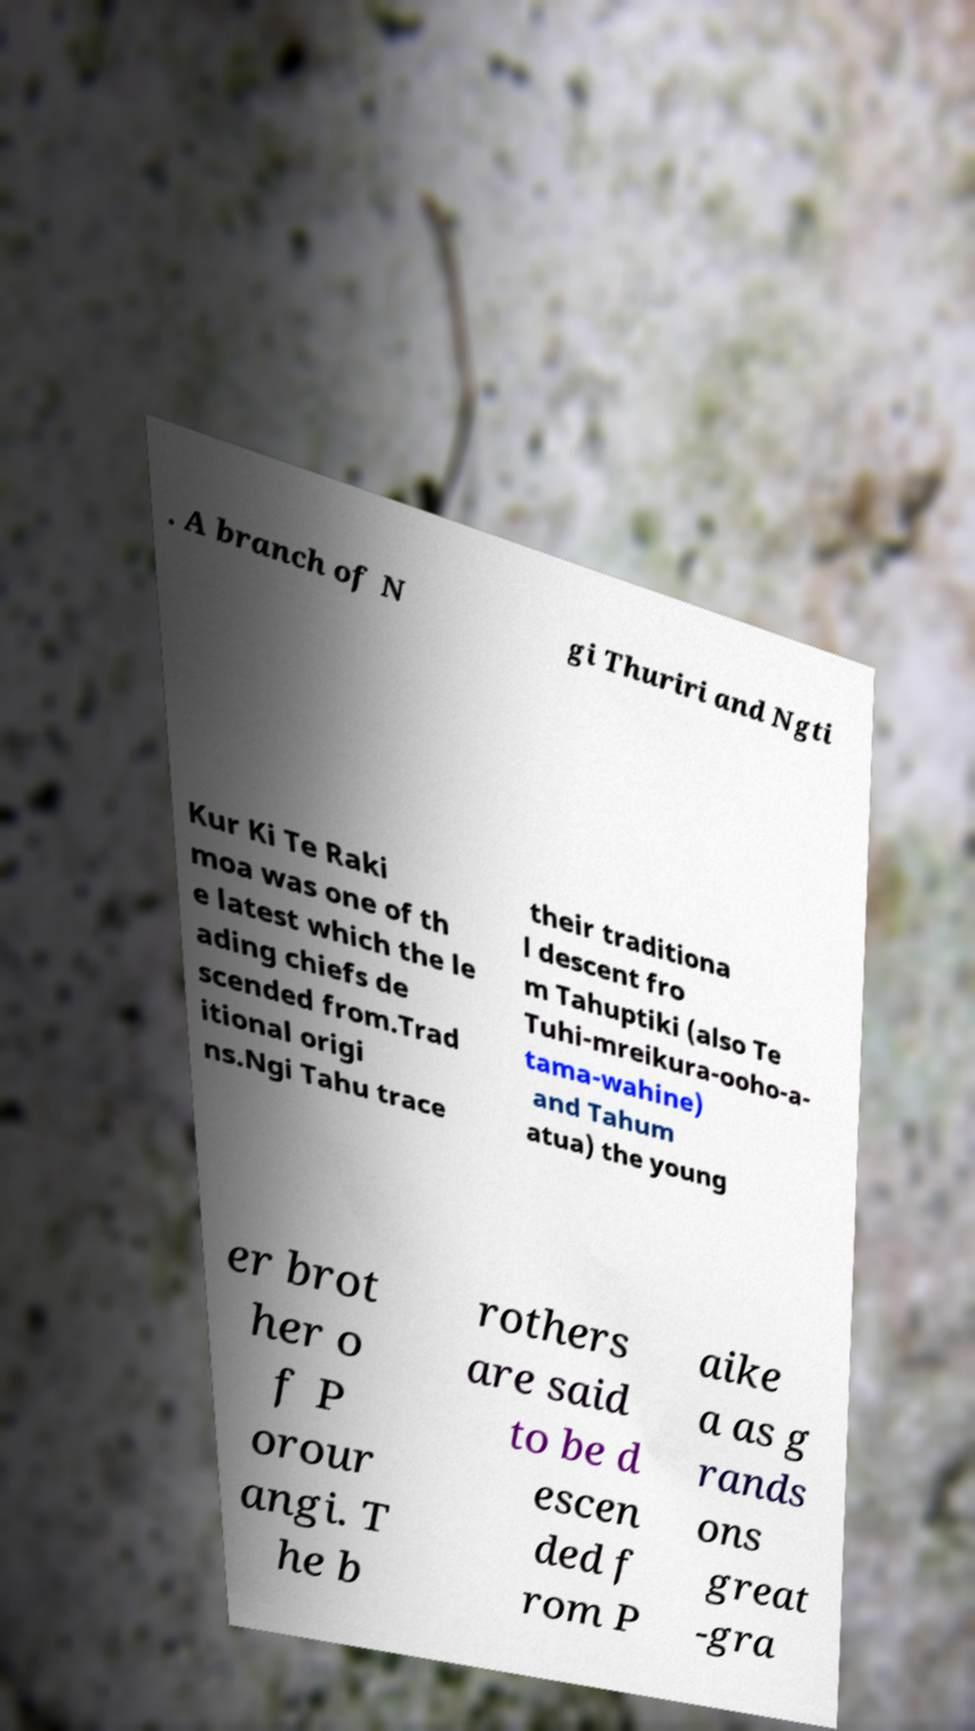Could you extract and type out the text from this image? . A branch of N gi Thuriri and Ngti Kur Ki Te Raki moa was one of th e latest which the le ading chiefs de scended from.Trad itional origi ns.Ngi Tahu trace their traditiona l descent fro m Tahuptiki (also Te Tuhi-mreikura-ooho-a- tama-wahine) and Tahum atua) the young er brot her o f P orour angi. T he b rothers are said to be d escen ded f rom P aike a as g rands ons great -gra 